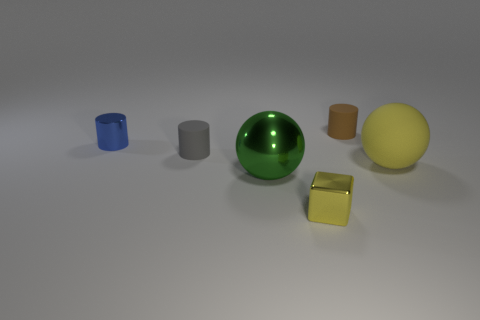Subtract all small matte cylinders. How many cylinders are left? 1 Add 3 blue metal cylinders. How many objects exist? 9 Subtract 2 cylinders. How many cylinders are left? 1 Subtract all yellow balls. How many balls are left? 1 Subtract 0 purple cubes. How many objects are left? 6 Subtract all spheres. How many objects are left? 4 Subtract all brown spheres. Subtract all cyan cubes. How many spheres are left? 2 Subtract all green shiny spheres. Subtract all large yellow matte cylinders. How many objects are left? 5 Add 6 green metal things. How many green metal things are left? 7 Add 2 shiny blocks. How many shiny blocks exist? 3 